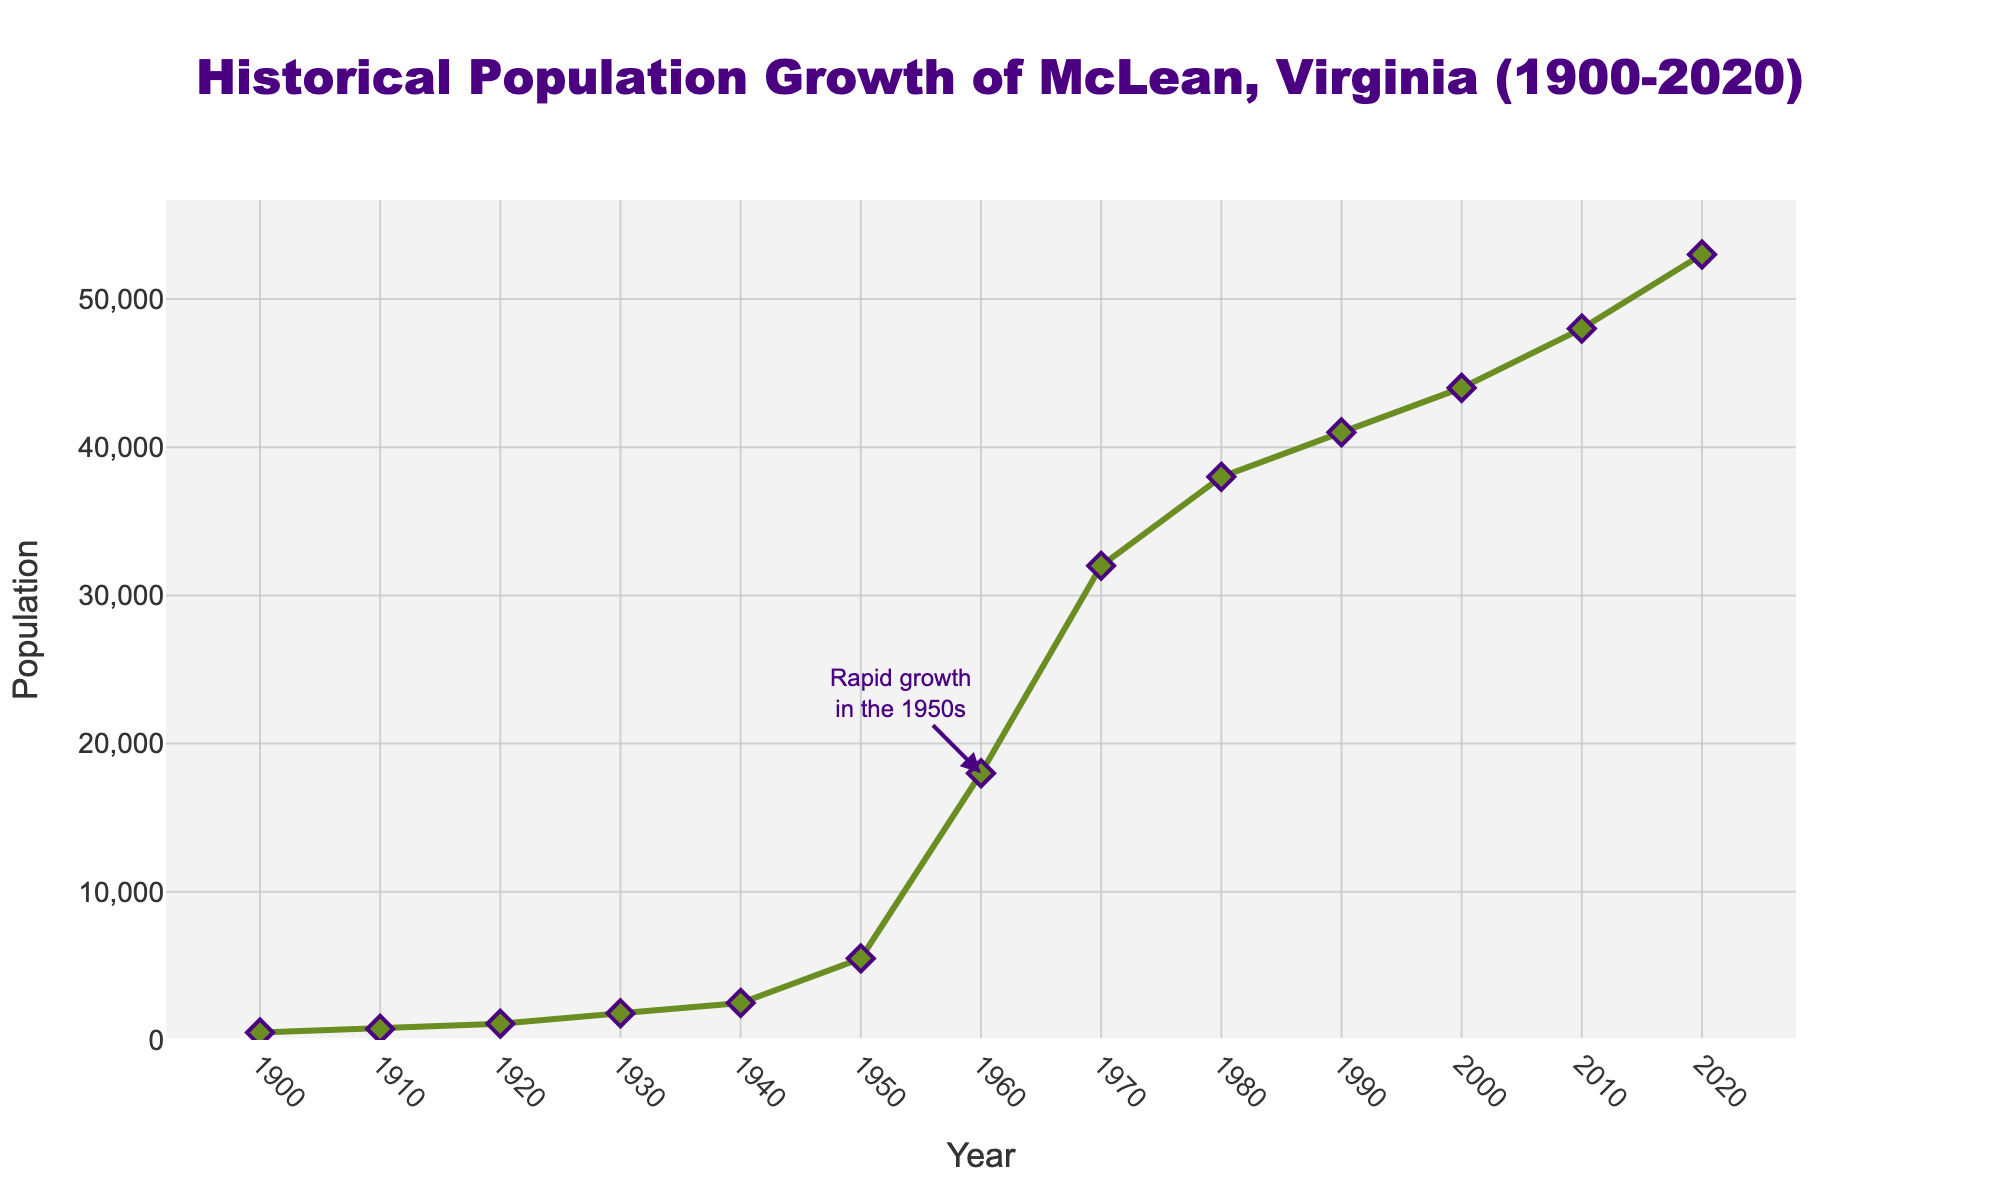What was the population of McLean, Virginia in 1920? Look at the data point for the Year 1920 on the line chart, which shows the population.
Answer: 1100 What decade saw the most rapid population growth in McLean, Virginia? Compare the population changes between each decade and identify the decade with the largest difference. The most significant increase happens between 1950 and 1960.
Answer: 1950-1960 By how much did the population of McLean increase between 1940 and 1950? Subtract the population of 1940 from the population of 1950: 5500 - 2500 = 3000.
Answer: 3000 Which year marked the beginning of a consistent rise in population without decline? Review the figure and determine the year from which the population starts increasing consistently. The upward trend starts after 1930.
Answer: 1930 What is the total population growth from 1900 to 2020? Subtract the population of 1900 from the population of 2020: 53000 - 500 = 52500.
Answer: 52500 How many times did the population double between 1900 and 1950? Calculate the population doubling events between 1900 and 1950: 500 (1900) -> 1000 (before 1910), 1000 -> 2000 (just before 1930), 2000 -> 4000 (before 1950), and 5500 in 1950. The population doubled two times between 1900 and 1950.
Answer: 2 times What visual element on the figure highlights a key historical event? Look at the annotations for any labels or arrows pointing to a significant event. There is an annotation on the chart pointing to the rapid growth in the 1950s.
Answer: Annotation What is the median population value for the recorded years? Find the median value by listing the populations in order and selecting the middle value, or the average of the two middle values if needed. The ordered populations are: 500, 750, 1100, 1800, 2500, 5500, 18000, 32000, 38000, 41000, 44000, 48000, 53000. The median value is the seventh value, which is 18000.
Answer: 18000 How did the population change from 1980 to 1990 compare to the change from 1990 to 2000? Calculate the population change for each period: from 1980 to 1990 it is 41000 - 38000 = 3000, and from 1990 to 2000 it is 44000 - 41000 = 3000. Both periods have the same change.
Answer: 3000 (each period) What is the approximate population growth rate from 2000 to 2020? Calculate the growth rate using the formula: (Population in 2020 - Population in 2000) / (Population in 2000). The calculation is (53000 - 44000) / 44000 ≈ 20.45%.
Answer: ~20.45% 